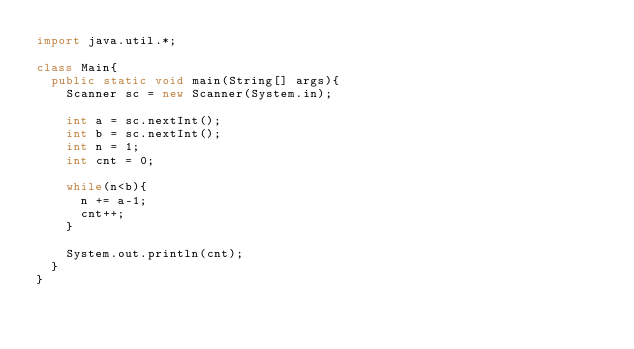<code> <loc_0><loc_0><loc_500><loc_500><_Java_>import java.util.*;

class Main{
  public static void main(String[] args){
    Scanner sc = new Scanner(System.in);
    
    int a = sc.nextInt();
    int b = sc.nextInt();
    int n = 1;
    int cnt = 0;
    
    while(n<b){
      n += a-1;
      cnt++;
    }
    
    System.out.println(cnt);
  }
}</code> 